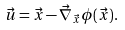<formula> <loc_0><loc_0><loc_500><loc_500>\vec { u } = \vec { x } - \vec { \nabla } _ { \vec { x } } \phi ( \vec { x } ) .</formula> 